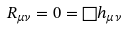<formula> <loc_0><loc_0><loc_500><loc_500>R _ { \mu \nu } = 0 = \Box h _ { \mu \nu }</formula> 